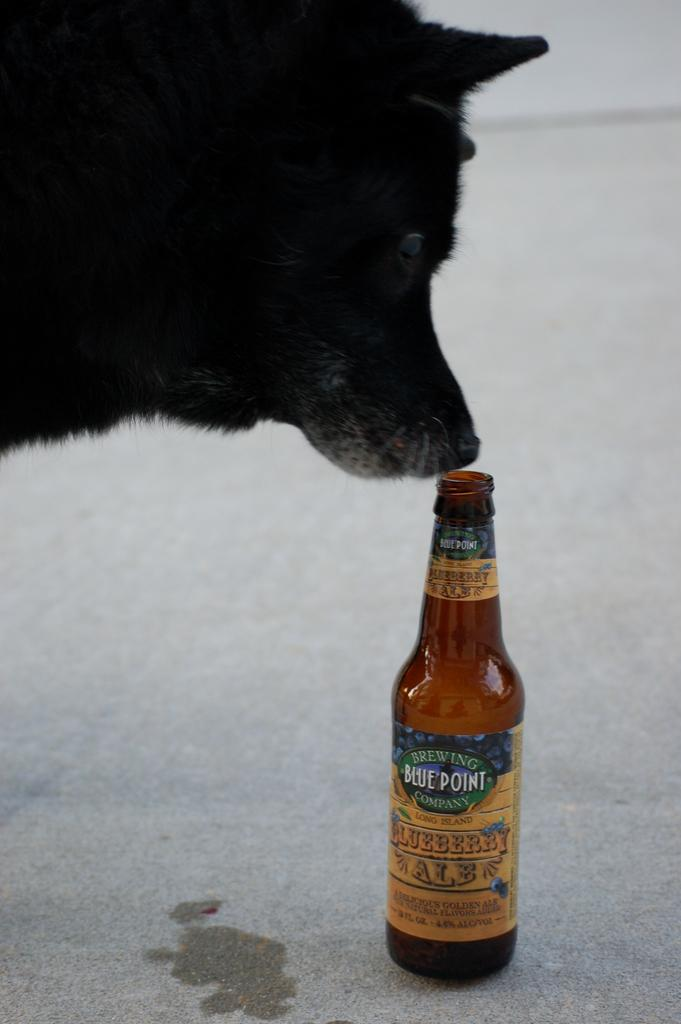What type of animal is in the image? There is a black color dog in the image. What object can be seen on the ground in the image? There is a bottle on the ground in the image. What type of ink is being used by the dog in the image? There is no ink or writing activity present in the image; it features a black color dog and a bottle on the ground. 